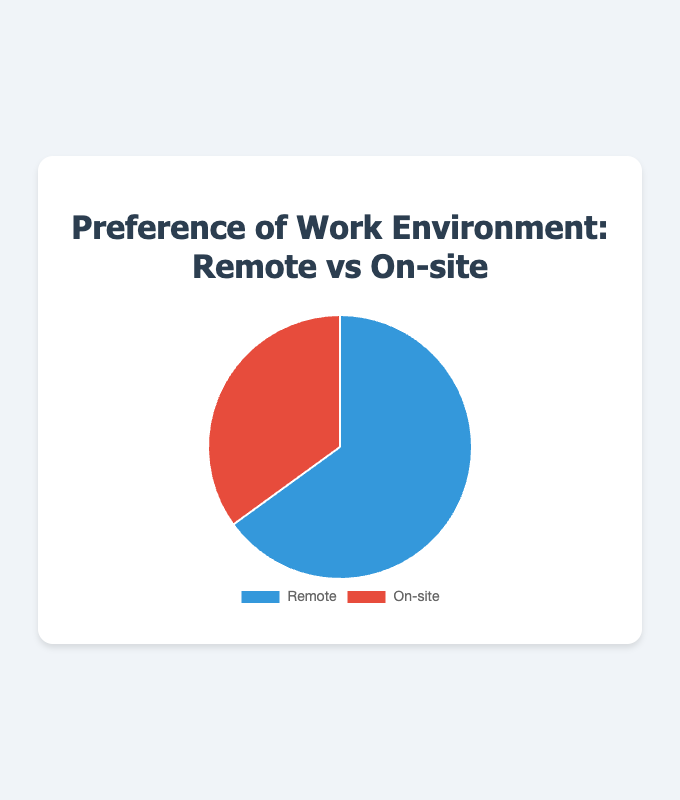What is the percentage of people who prefer working remotely? Looking at the pie chart, the segment representing Remote preference indicates a value of 65%.
Answer: 65% How much greater is the preference for remote work compared to on-site work? Subtract the percentage of on-site preference (35%) from the remote preference (65%) to find the difference: 65% - 35% = 30%.
Answer: 30% What is the ratio of people preferring remote work to those preferring on-site work? The preference for remote work is 65%, and for on-site work is 35%. The ratio is 65:35. To simplify, divide both numbers by their greatest common divisor (5): 65/5 = 13, 35/5 = 7. Hence, the ratio is 13:7.
Answer: 13:7 What percentage of people prefer working on-site? Looking at the pie chart, the segment representing On-site preference shows a value of 35%.
Answer: 35% What is the total percentage of people regardless of their work environment preference? The total percentage includes both remote and on-site preferences, which sum up to 100% (65% + 35%).
Answer: 100% Which work environment has a higher preference according to the pie chart? Comparing the two segments, the Remote work environment segment is larger at 65% compared to the On-site segment at 35%. Thus, Remote work has a higher preference.
Answer: Remote If the total number of respondents is 200, how many people prefer remote work? Given that 65% prefer remote work, calculate 65% of 200 by multiplying: 200 * 0.65 = 130 people.
Answer: 130 If the total number of respondents is 200, how many people prefer working on-site? Given that 35% prefer working on-site, calculate 35% of 200 by multiplying: 200 * 0.35 = 70 people.
Answer: 70 What are the colors representing remote and on-site preferences? The visual attributes show that the segment for Remote preference is colored blue and the segment for On-site is colored red.
Answer: Blue and Red If the chart were divided into four equal segments, how much more would each segment represent compared to the current segment for on-site preference? Each equal segment of the chart would represent 25%. The current on-site preference is 35%. The difference for each equal segment would be 25% - 35% = -10%.
Answer: -10% 